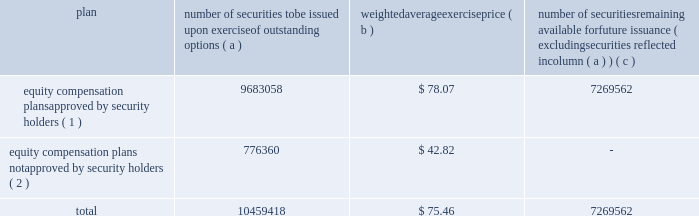Equity compensation plan information the table summarizes the equity compensation plan information as of december 31 , 2011 .
Information is included for equity compensation plans approved by the stockholders and equity compensation plans not approved by the stockholders .
Number of securities to be issued upon exercise of outstanding options weighted average exercise number of securities remaining available for future issuance ( excluding securities reflected in column ( a ) ) equity compensation plans approved by security holders ( 1 ) 9683058 $ 78.07 7269562 equity compensation plans not approved by security holders ( 2 ) 776360 $ 42.82 .
( 1 ) includes the equity ownership plan , which was approved by the shareholders on may 15 , 1998 , the 2007 equity ownership plan and the 2011 equity ownership plan .
The 2007 equity ownership plan was approved by entergy corporation shareholders on may 12 , 2006 , and 7000000 shares of entergy corporation common stock can be issued , with no more than 2000000 shares available for non-option grants .
The 2011 equity ownership plan was approved by entergy corporation shareholders on may 6 , 2011 , and 5500000 shares of entergy corporation common stock can be issued from the 2011 equity ownership plan , with no more than 2000000 shares available for incentive stock option grants .
The equity ownership plan , the 2007 equity ownership plan and the 2011 equity ownership plan ( the 201cplans 201d ) are administered by the personnel committee of the board of directors ( other than with respect to awards granted to non-employee directors , which awards are administered by the entire board of directors ) .
Eligibility under the plans is limited to the non-employee directors and to the officers and employees of an entergy system employer and any corporation 80% ( 80 % ) or more of whose stock ( based on voting power ) or value is owned , directly or indirectly , by entergy corporation .
The plans provide for the issuance of stock options , restricted shares , equity awards ( units whose value is related to the value of shares of the common stock but do not represent actual shares of common stock ) , performance awards ( performance shares or units valued by reference to shares of common stock or performance units valued by reference to financial measures or property other than common stock ) and other stock-based awards .
( 2 ) entergy has a board-approved stock-based compensation plan .
However , effective may 9 , 2003 , the board has directed that no further awards be issued under that plan .
Item 13 .
Certain relationships and related transactions and director independence for information regarding certain relationships , related transactions and director independence of entergy corporation , see the proxy statement under the headings 201ccorporate governance - director independence 201d and 201ctransactions with related persons , 201d which information is incorporated herein by reference .
Since december 31 , 2010 , none of the subsidiaries or any of their affiliates has participated in any transaction involving an amount in excess of $ 120000 in which any director or executive officer of any of the subsidiaries , any nominee for director , or any immediate family member of the foregoing had a material interest as contemplated by item 404 ( a ) of regulation s-k ( 201crelated party transactions 201d ) .
Entergy corporation 2019s board of directors has adopted written policies and procedures for the review , approval or ratification of related party transactions .
Under these policies and procedures , the corporate governance committee , or a subcommittee of the board of directors of entergy corporation composed of .
What is thee total value of outstanding security options? 
Computations: (9683058 - 78.07)
Answer: 9682979.93. 